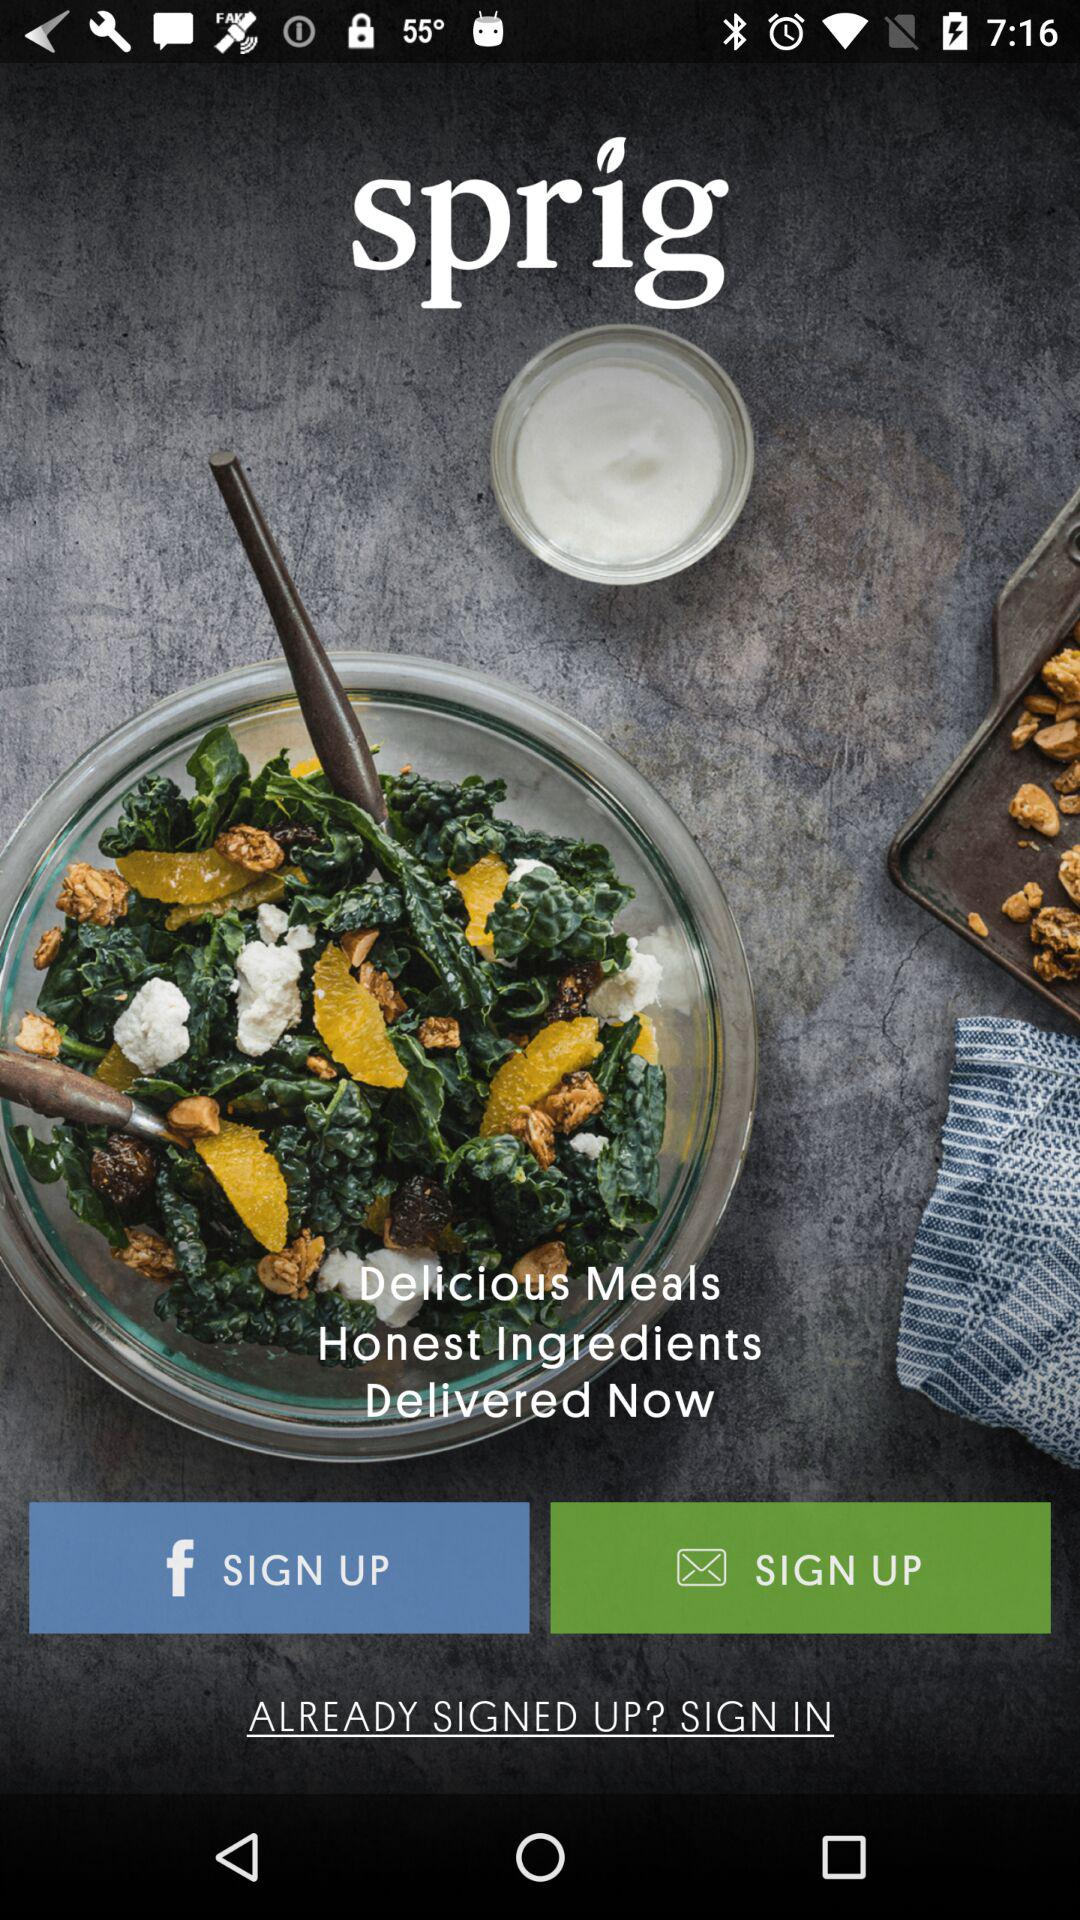What is the name of the application? The name of the application is "sprig". 